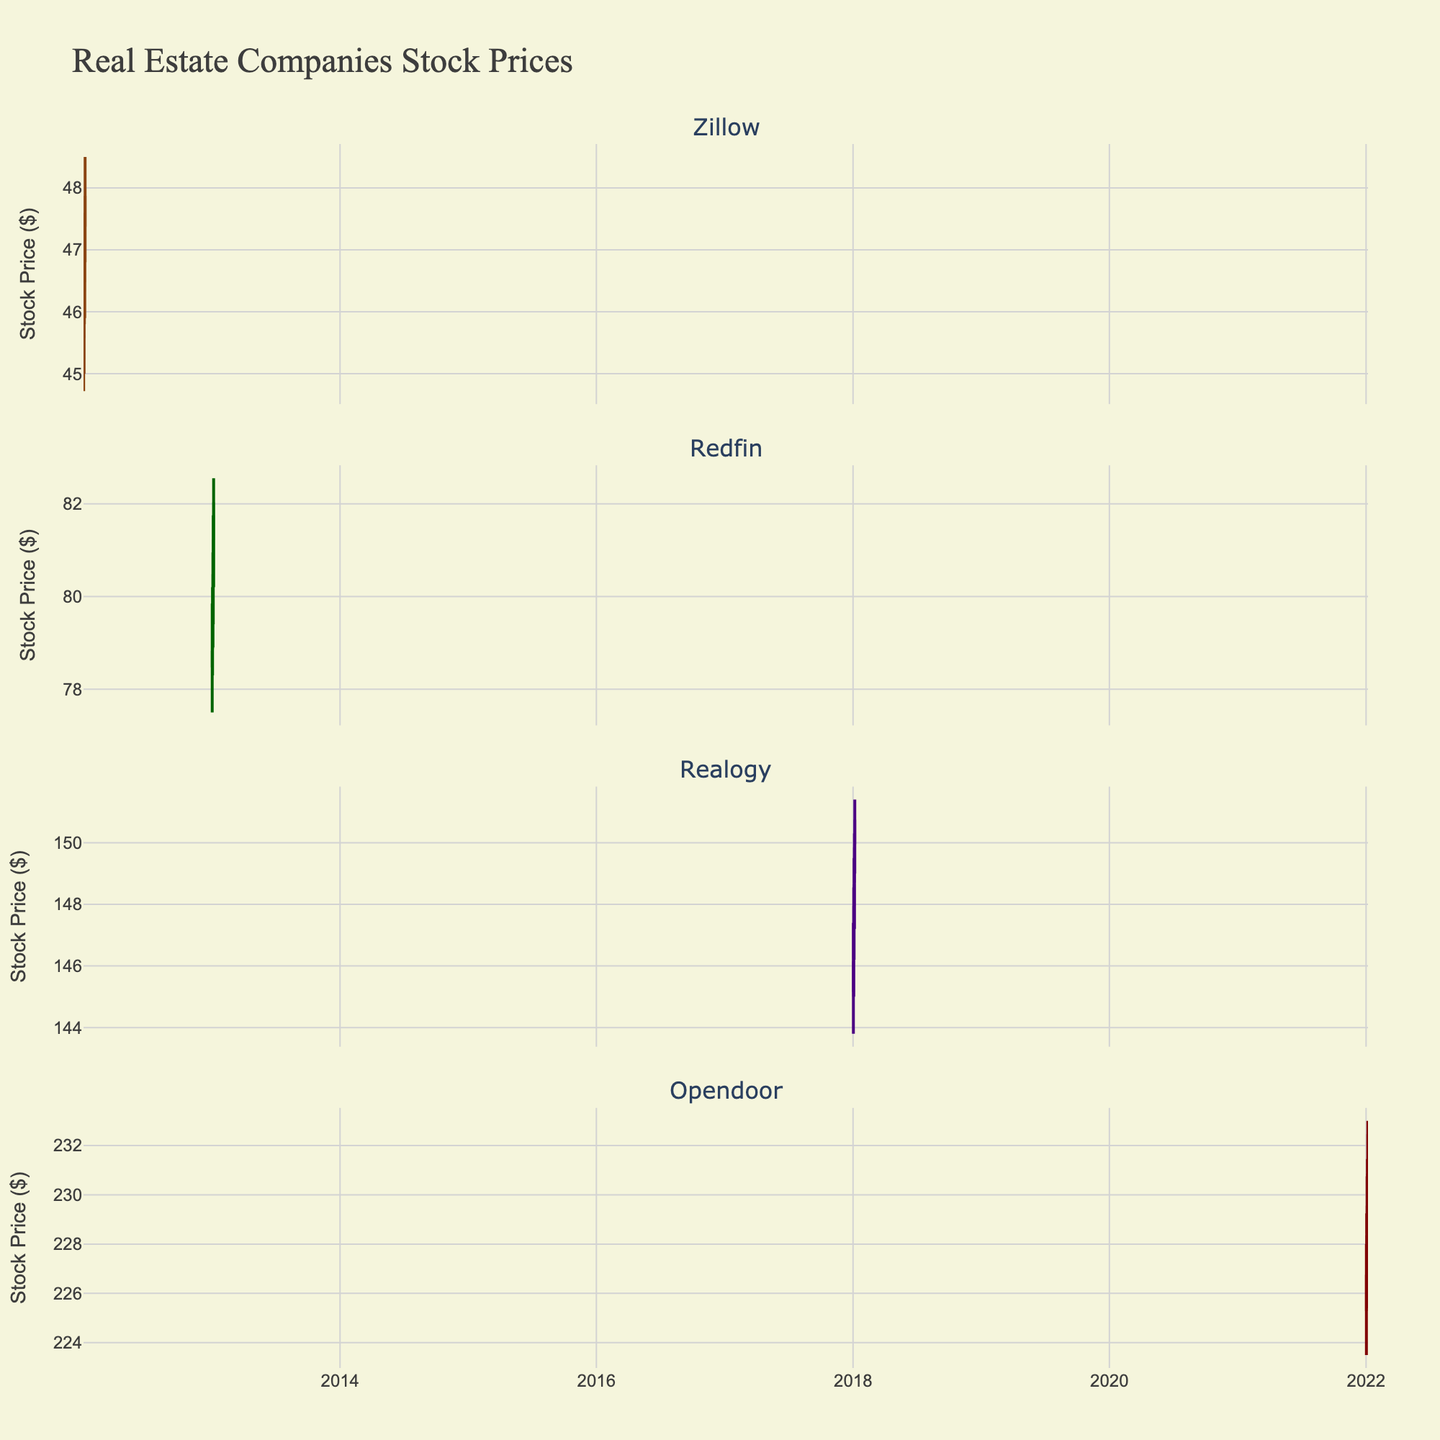How many companies are shown in the candlestick plot? There are four rows in the plot and each row represents one company. This indicates there are four companies shown.
Answer: 4 Which company has the highest stock price on the closing date provided in the data? By analyzing the highest candlestick close values for each company, Opendoor has the highest closing value at 232.40 on 2022-01-06.
Answer: Opendoor What is the closing price difference between Zillow and Redfin on the first dates provided for each? Zillow's closing price on 2012-01-02 is 45.60. Redfin's closing price on 2013-01-02 is 78.80. The difference is 78.80 - 45.60 = 33.20.
Answer: 33.20 Which company had the most significant increase in closing stock price over the period shown? By comparing the starting and ending closing prices for each company, Zillow increased from 45.60 to 47.85, Redfin from 78.80 to 82.00, Realogy from 146.10 to 150.70, and Opendoor from 226.70 to 232.40. Opendoor had the most significant increase of 232.40 - 226.70 = 5.70.
Answer: Opendoor What is the range of stock prices for Realogy on 2018-01-02? The high and low prices for Realogy on 2018-01-02 are 147.40 and 143.80, respectively. The range is 147.40 - 143.80 = 3.60.
Answer: 3.60 Among the companies listed, which one has the least stock price volatility based on the candlestick lengths visually? By observing the candlestick lengths, which indicate the difference between high and low prices, Zillow's candlesticks appear to be the shortest, suggesting least volatility.
Answer: Zillow Is there any company that has predominantly increasing stock prices over the given dates? Opendoor shows predominantly increasing candlesticks (majority are white indicating increase) throughout the given dates from 2022-01-02 to 2022-01-06.
Answer: Opendoor What is the average closing price for Zillow over the dates provided? The closing prices for Zillow are 45.60, 46.30, 46.95, 47.35, and 47.85. The sum is 234.05, and the average is 234.05/5 = 46.81.
Answer: 46.81 Between Zillow and Realogy, which company had a higher open price at the start of the given data? Zillow had an open price of 45.26 on 2012-01-02; Realogy had an open price of 145.20 on 2018-01-02. Therefore, Realogy had the higher open price.
Answer: Realogy What notable pattern can be observed in the candlestick plot for Redfin? Redfin's candlesticks show an upward trend over the dates provided, indicating a gradual increase in stock price from 78.80 to 82.00.
Answer: Upward trend 